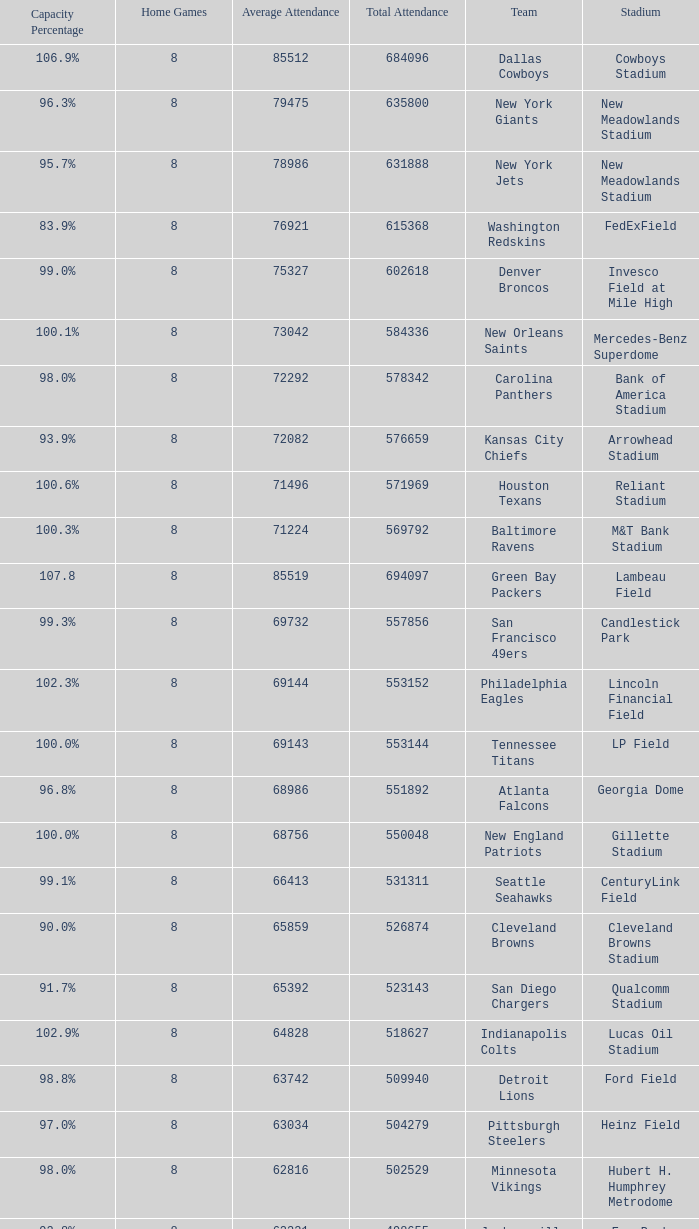Give me the full table as a dictionary. {'header': ['Capacity Percentage', 'Home Games', 'Average Attendance', 'Total Attendance', 'Team', 'Stadium'], 'rows': [['106.9%', '8', '85512', '684096', 'Dallas Cowboys', 'Cowboys Stadium'], ['96.3%', '8', '79475', '635800', 'New York Giants', 'New Meadowlands Stadium'], ['95.7%', '8', '78986', '631888', 'New York Jets', 'New Meadowlands Stadium'], ['83.9%', '8', '76921', '615368', 'Washington Redskins', 'FedExField'], ['99.0%', '8', '75327', '602618', 'Denver Broncos', 'Invesco Field at Mile High'], ['100.1%', '8', '73042', '584336', 'New Orleans Saints', 'Mercedes-Benz Superdome'], ['98.0%', '8', '72292', '578342', 'Carolina Panthers', 'Bank of America Stadium'], ['93.9%', '8', '72082', '576659', 'Kansas City Chiefs', 'Arrowhead Stadium'], ['100.6%', '8', '71496', '571969', 'Houston Texans', 'Reliant Stadium'], ['100.3%', '8', '71224', '569792', 'Baltimore Ravens', 'M&T Bank Stadium'], ['107.8', '8', '85519', '694097', 'Green Bay Packers', 'Lambeau Field'], ['99.3%', '8', '69732', '557856', 'San Francisco 49ers', 'Candlestick Park'], ['102.3%', '8', '69144', '553152', 'Philadelphia Eagles', 'Lincoln Financial Field'], ['100.0%', '8', '69143', '553144', 'Tennessee Titans', 'LP Field'], ['96.8%', '8', '68986', '551892', 'Atlanta Falcons', 'Georgia Dome'], ['100.0%', '8', '68756', '550048', 'New England Patriots', 'Gillette Stadium'], ['99.1%', '8', '66413', '531311', 'Seattle Seahawks', 'CenturyLink Field'], ['90.0%', '8', '65859', '526874', 'Cleveland Browns', 'Cleveland Browns Stadium'], ['91.7%', '8', '65392', '523143', 'San Diego Chargers', 'Qualcomm Stadium'], ['102.9%', '8', '64828', '518627', 'Indianapolis Colts', 'Lucas Oil Stadium'], ['98.8%', '8', '63742', '509940', 'Detroit Lions', 'Ford Field'], ['97.0%', '8', '63034', '504279', 'Pittsburgh Steelers', 'Heinz Field'], ['98.0%', '8', '62816', '502529', 'Minnesota Vikings', 'Hubert H. Humphrey Metrodome'], ['92.8%', '8', '62331', '498655', 'Jacksonville Jaguars', 'EverBank Field'], ['101.0%', '8', '62145', '497166', 'Chicago Bears', 'Soldier Field'], ['96.5%', '8', '61181', '489455', 'Arizona Cardinals', 'University of Phoenix Stadium'], ['81.0%', '8', '60886', '487089', 'Miami Dolphins', 'Sun Life Stadium'], ['94.0%', '8', '59242', '473938', 'Oakland Raiders', 'Oakland-Alameda County Coliseum'], ['86.3%', '8', '56394', '451153', 'St. Louis Rams', 'Edward Jones Dome'], ['85.8%', '7', '62694', '438864', 'Buffalo Bills', 'Ralph Wilson Stadium **'], ['86.2%', '7', '56614', '396300', 'Tampa Bay Buccaneers', 'Raymond James Stadium *']]} What is the capacity percentage when the total attendance is 509940? 98.8%. 